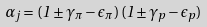<formula> <loc_0><loc_0><loc_500><loc_500>\alpha _ { j } = ( 1 \pm \gamma _ { \pi } - \epsilon _ { \pi } ) \, ( 1 \pm \gamma _ { p } - \epsilon _ { p } )</formula> 